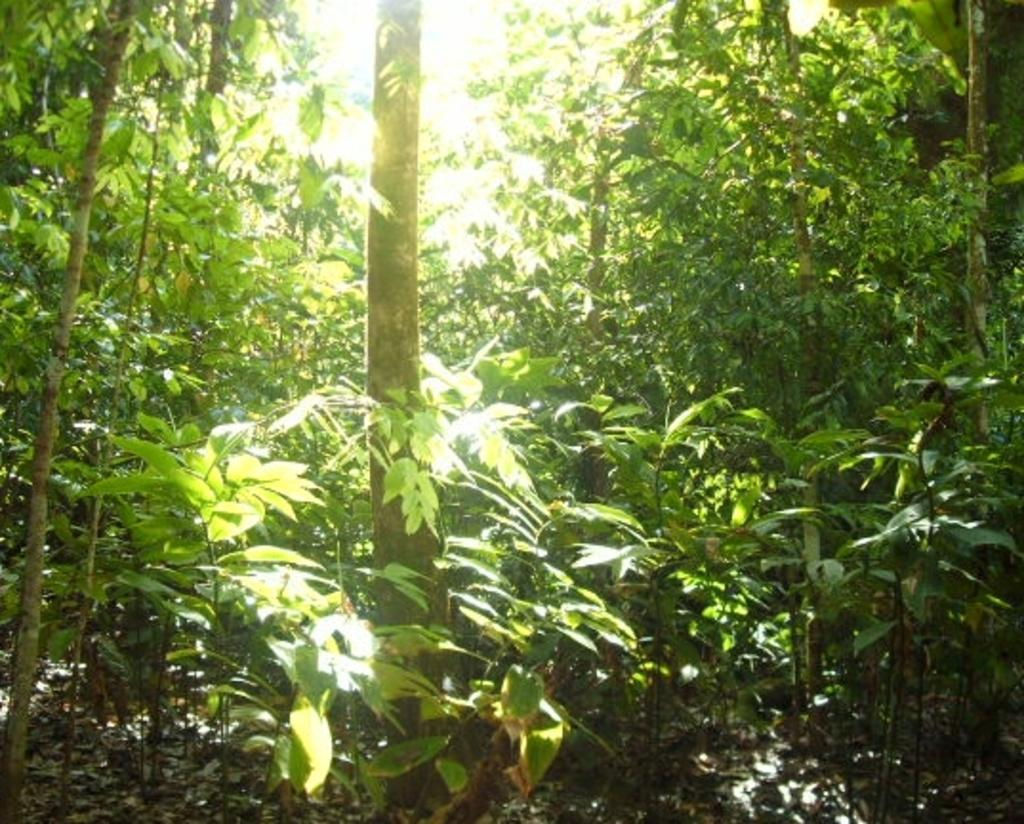What type of vegetation can be seen in the image? There are trees in the image. What can be observed on the ground in the image? There are leaves on the ground in the image. What type of fuel is being used by the police car in the image? There is no police car present in the image, so it is not possible to determine what type of fuel is being used. 